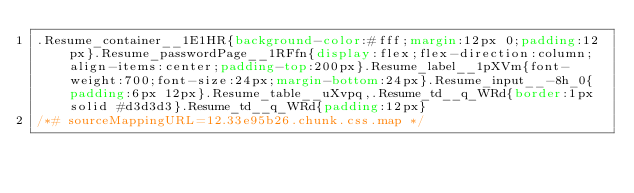Convert code to text. <code><loc_0><loc_0><loc_500><loc_500><_CSS_>.Resume_container__1E1HR{background-color:#fff;margin:12px 0;padding:12px}.Resume_passwordPage__1RFfn{display:flex;flex-direction:column;align-items:center;padding-top:200px}.Resume_label__1pXVm{font-weight:700;font-size:24px;margin-bottom:24px}.Resume_input__-8h_0{padding:6px 12px}.Resume_table__uXvpq,.Resume_td__q_WRd{border:1px solid #d3d3d3}.Resume_td__q_WRd{padding:12px}
/*# sourceMappingURL=12.33e95b26.chunk.css.map */</code> 